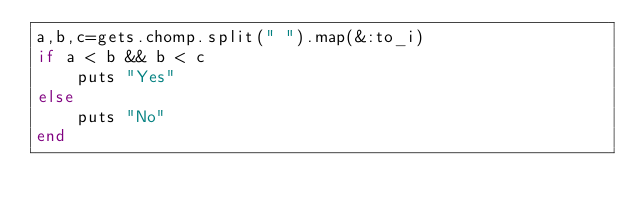<code> <loc_0><loc_0><loc_500><loc_500><_Ruby_>a,b,c=gets.chomp.split(" ").map(&:to_i)
if a < b && b < c
	puts "Yes"
else
	puts "No"
end</code> 